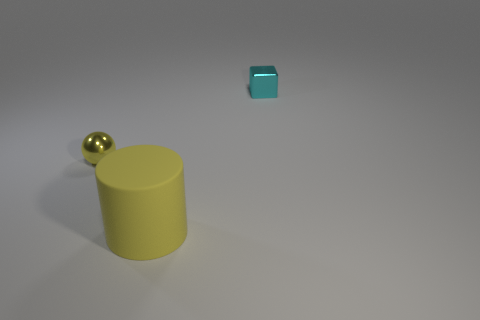There is a tiny object that is on the left side of the tiny shiny block; what material is it?
Ensure brevity in your answer.  Metal. There is a yellow metallic object; is its shape the same as the tiny thing to the right of the large yellow object?
Ensure brevity in your answer.  No. What is the object that is both on the right side of the sphere and behind the big yellow cylinder made of?
Make the answer very short. Metal. There is a sphere that is the same size as the shiny cube; what is its color?
Make the answer very short. Yellow. Is the small block made of the same material as the thing in front of the small yellow shiny sphere?
Provide a short and direct response. No. What number of other things are the same size as the cube?
Provide a short and direct response. 1. There is a thing in front of the small thing to the left of the big yellow thing; is there a yellow metal sphere left of it?
Ensure brevity in your answer.  Yes. The cylinder is what size?
Keep it short and to the point. Large. What is the size of the metallic object that is behind the sphere?
Your answer should be compact. Small. Do the metal object behind the shiny sphere and the tiny yellow object have the same size?
Your answer should be very brief. Yes. 